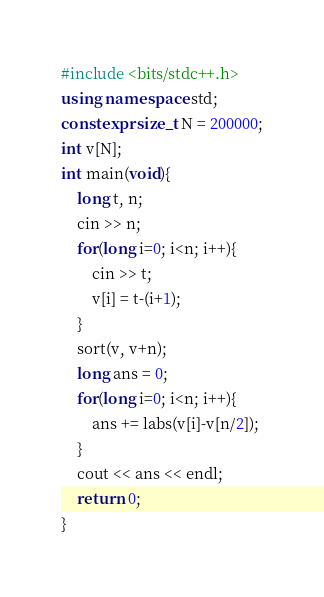<code> <loc_0><loc_0><loc_500><loc_500><_C++_>#include <bits/stdc++.h>
using namespace std;
constexpr size_t N = 200000;
int v[N];
int main(void){
    long t, n;
    cin >> n;
    for(long i=0; i<n; i++){
        cin >> t;
        v[i] = t-(i+1);
    }
    sort(v, v+n);
    long ans = 0;
    for(long i=0; i<n; i++){
        ans += labs(v[i]-v[n/2]);
    }
    cout << ans << endl;
    return 0;
}
</code> 